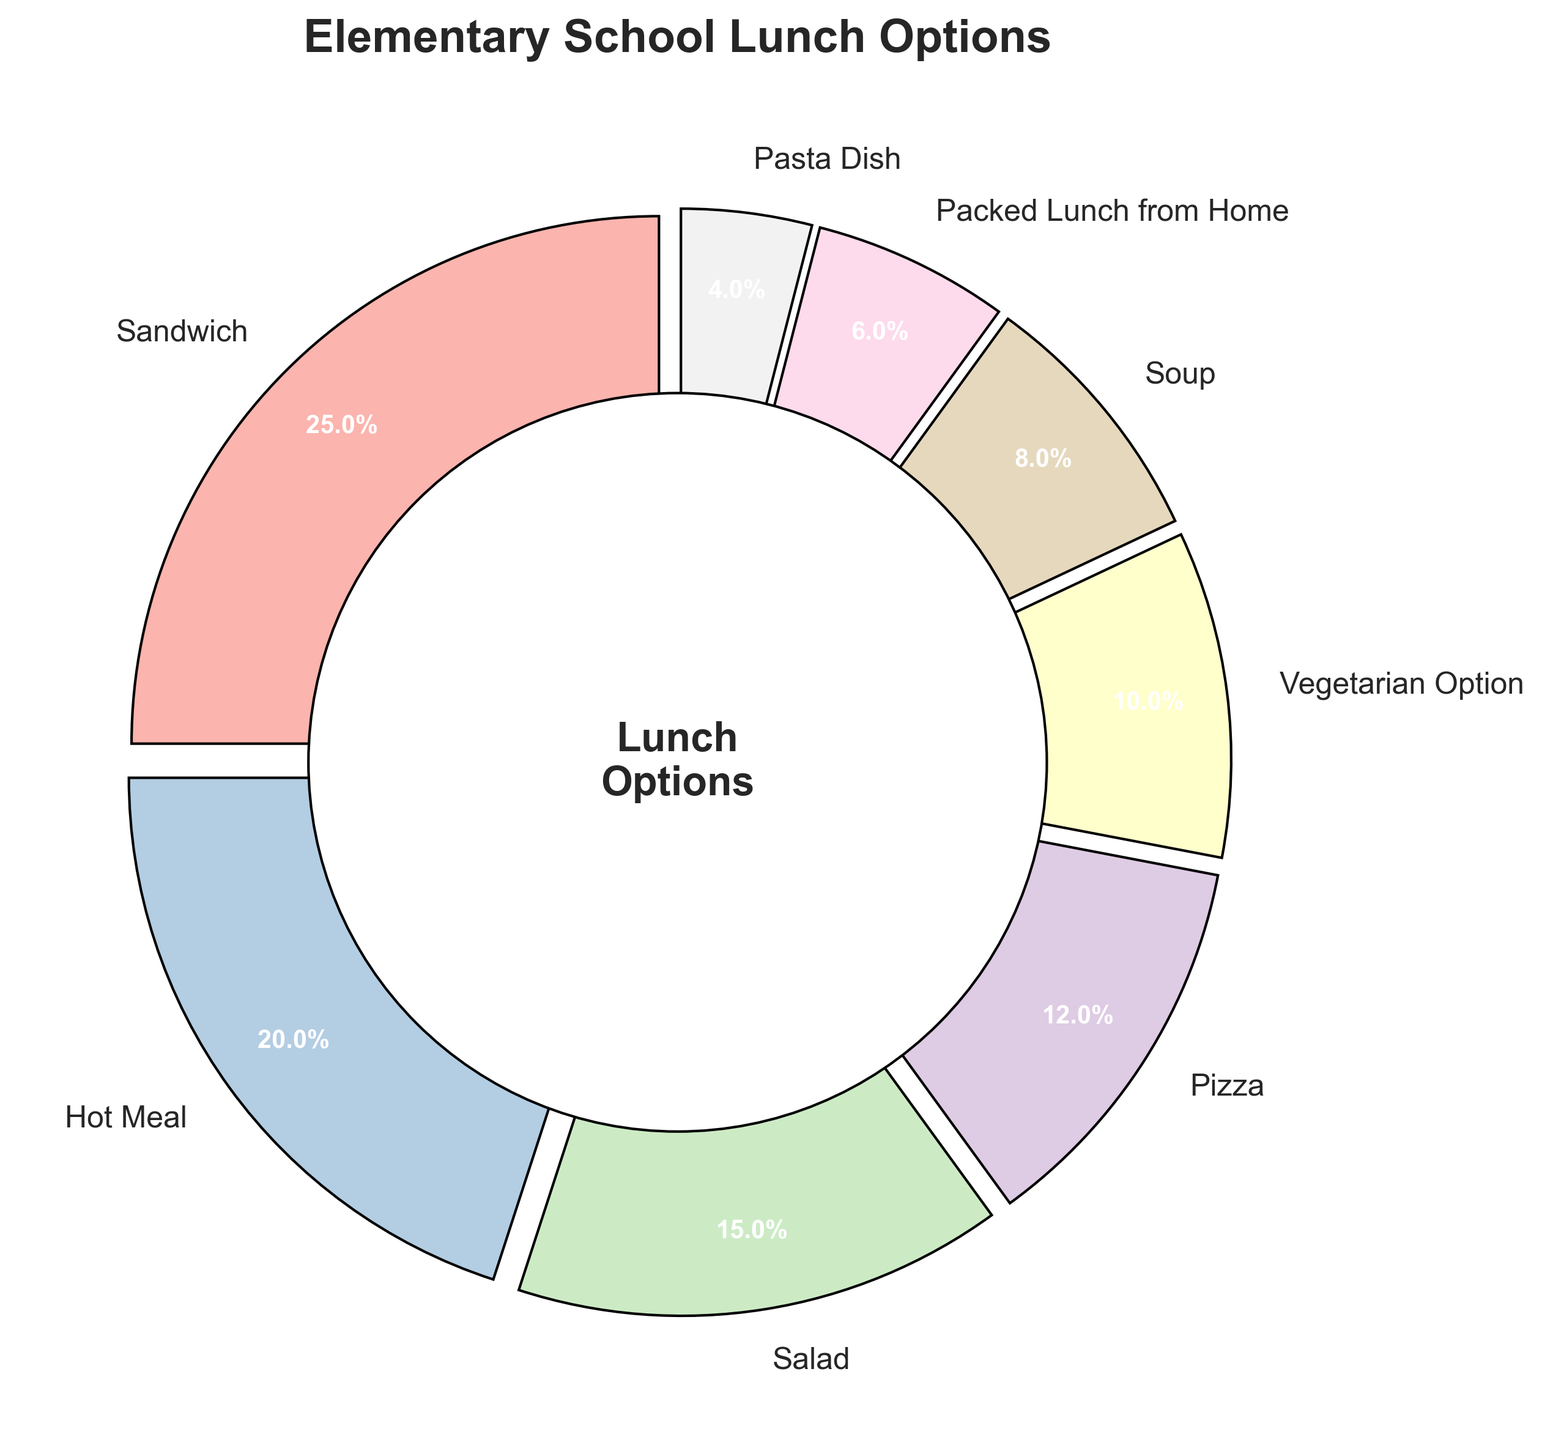Which lunch option is the most popular? By looking at the pie chart, we can identify that the largest segment represents the most popular option. The Sandwich segment is the largest, which means it is the most popular.
Answer: Sandwich How many lunch options have a percentage greater than 10%? To answer this, we need to count all the segments that have a slice labeled with a percentage greater than 10%. The options are Sandwich (25%), Hot Meal (20%), Salad (15%), and Pizza (12%).
Answer: 4 Which is more popular, Soup or Pasta Dish? By comparing the two segments visually, we can see that the Soup slice is larger than the Pasta Dish slice (8% vs. 4%).
Answer: Soup What is the combined percentage of Pizza and Vegetarian Option? To find the combined percentage, we add the percentages of the Pizza and Vegetarian Option segments. Pizza is 12% and Vegetarian Option is 10%, so 12% + 10% = 22%.
Answer: 22% What is the difference in percentage between the most and least popular lunch options? First, identify the most and least popular options. The most popular is Sandwich (25%) and the least popular is Pasta Dish (4%). The difference is 25% - 4% = 21%.
Answer: 21% Which category is represented by the greenish segment in the pie chart? By looking at the color assigned to each segment in the chart, the greenish segment represents the category Salad.
Answer: Salad How many categories have a percentage less than the packed lunch from home option? Packed Lunch from Home is 6%. So, we need to count the segments with percentages less than 6%. The only option is Pasta Dish (4%).
Answer: 1 Is the percentage of Hot Meal and Vegetarian Option together greater or less than the percentage of Sandwich? Calculate the sum of Hot Meal (20%) and Vegetarian Option (10%) to see if it is greater or less than Sandwich (25%). The sum is 20% + 10% = 30%, which is greater than 25%.
Answer: Greater If we combine the percentages for Pasta Dish, Packed Lunch from Home, and Soup, what is the total percentage? Sum the percentages for Pasta Dish (4%), Packed Lunch from Home (6%), and Soup (8%). The total is 4% + 6% + 8% = 18%.
Answer: 18% 